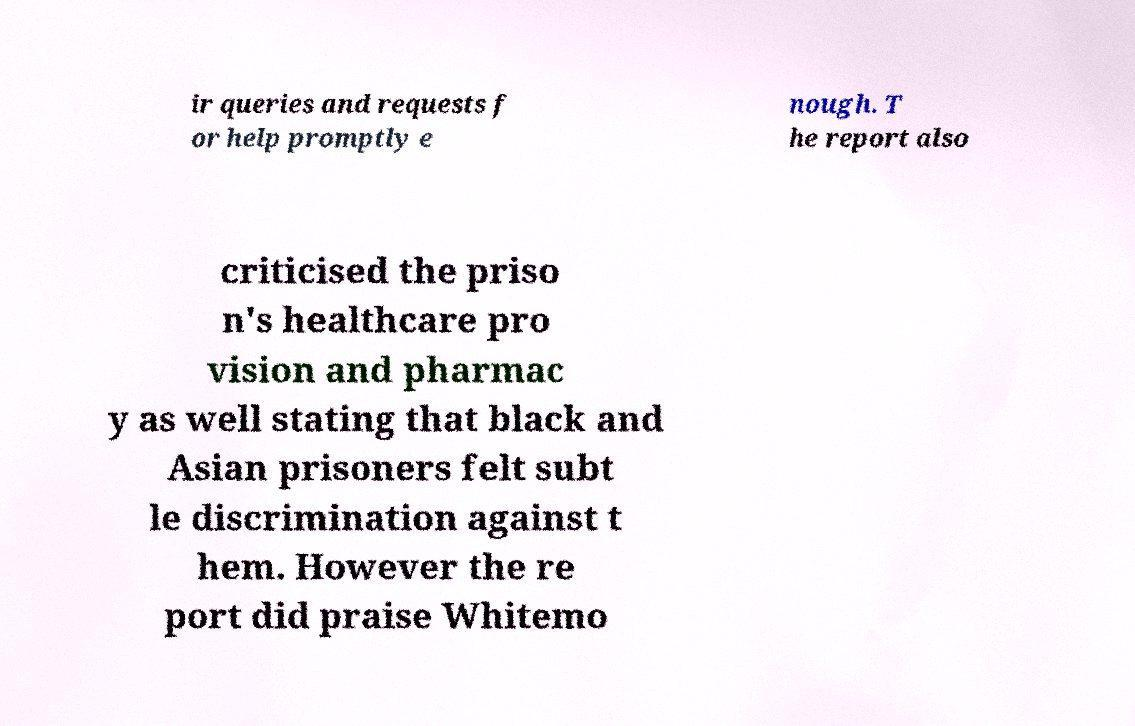Please identify and transcribe the text found in this image. ir queries and requests f or help promptly e nough. T he report also criticised the priso n's healthcare pro vision and pharmac y as well stating that black and Asian prisoners felt subt le discrimination against t hem. However the re port did praise Whitemo 